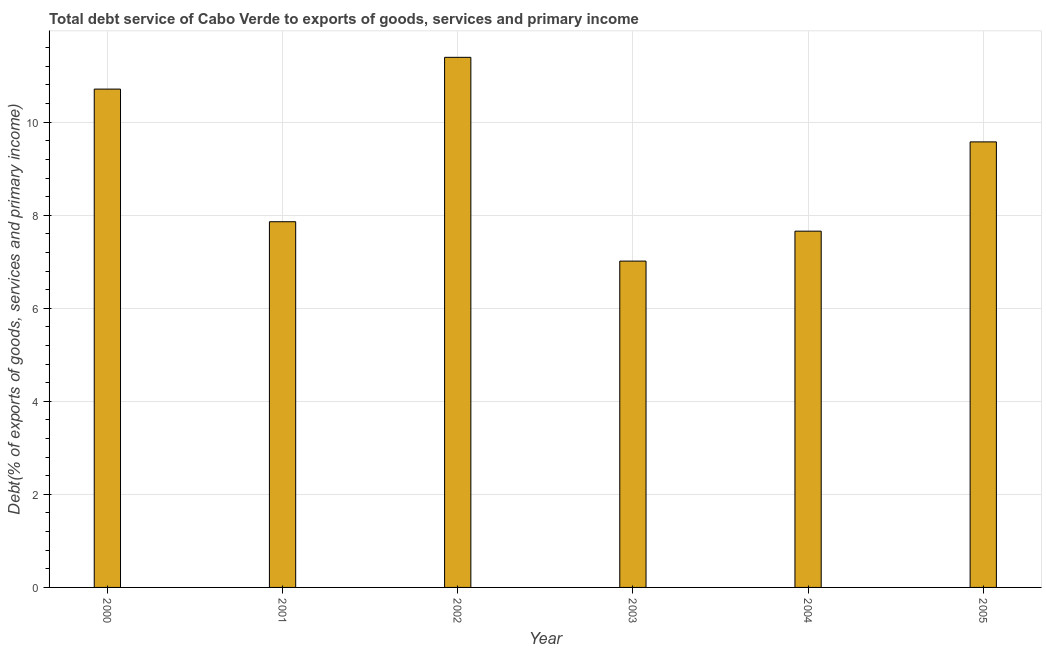Does the graph contain any zero values?
Provide a succinct answer. No. Does the graph contain grids?
Give a very brief answer. Yes. What is the title of the graph?
Keep it short and to the point. Total debt service of Cabo Verde to exports of goods, services and primary income. What is the label or title of the Y-axis?
Provide a short and direct response. Debt(% of exports of goods, services and primary income). What is the total debt service in 2004?
Your response must be concise. 7.66. Across all years, what is the maximum total debt service?
Your answer should be very brief. 11.39. Across all years, what is the minimum total debt service?
Ensure brevity in your answer.  7.01. In which year was the total debt service maximum?
Make the answer very short. 2002. What is the sum of the total debt service?
Keep it short and to the point. 54.21. What is the difference between the total debt service in 2001 and 2004?
Make the answer very short. 0.2. What is the average total debt service per year?
Make the answer very short. 9.04. What is the median total debt service?
Make the answer very short. 8.72. Is the total debt service in 2000 less than that in 2004?
Offer a terse response. No. Is the difference between the total debt service in 2003 and 2004 greater than the difference between any two years?
Provide a succinct answer. No. What is the difference between the highest and the second highest total debt service?
Keep it short and to the point. 0.68. Is the sum of the total debt service in 2002 and 2004 greater than the maximum total debt service across all years?
Offer a very short reply. Yes. What is the difference between the highest and the lowest total debt service?
Your response must be concise. 4.38. Are all the bars in the graph horizontal?
Your answer should be very brief. No. How many years are there in the graph?
Your answer should be very brief. 6. Are the values on the major ticks of Y-axis written in scientific E-notation?
Provide a succinct answer. No. What is the Debt(% of exports of goods, services and primary income) of 2000?
Your response must be concise. 10.71. What is the Debt(% of exports of goods, services and primary income) of 2001?
Offer a terse response. 7.86. What is the Debt(% of exports of goods, services and primary income) of 2002?
Ensure brevity in your answer.  11.39. What is the Debt(% of exports of goods, services and primary income) in 2003?
Offer a terse response. 7.01. What is the Debt(% of exports of goods, services and primary income) in 2004?
Make the answer very short. 7.66. What is the Debt(% of exports of goods, services and primary income) in 2005?
Offer a terse response. 9.58. What is the difference between the Debt(% of exports of goods, services and primary income) in 2000 and 2001?
Keep it short and to the point. 2.85. What is the difference between the Debt(% of exports of goods, services and primary income) in 2000 and 2002?
Offer a terse response. -0.68. What is the difference between the Debt(% of exports of goods, services and primary income) in 2000 and 2003?
Offer a very short reply. 3.7. What is the difference between the Debt(% of exports of goods, services and primary income) in 2000 and 2004?
Keep it short and to the point. 3.05. What is the difference between the Debt(% of exports of goods, services and primary income) in 2000 and 2005?
Make the answer very short. 1.13. What is the difference between the Debt(% of exports of goods, services and primary income) in 2001 and 2002?
Provide a short and direct response. -3.53. What is the difference between the Debt(% of exports of goods, services and primary income) in 2001 and 2003?
Offer a terse response. 0.85. What is the difference between the Debt(% of exports of goods, services and primary income) in 2001 and 2004?
Provide a succinct answer. 0.2. What is the difference between the Debt(% of exports of goods, services and primary income) in 2001 and 2005?
Your answer should be very brief. -1.72. What is the difference between the Debt(% of exports of goods, services and primary income) in 2002 and 2003?
Keep it short and to the point. 4.38. What is the difference between the Debt(% of exports of goods, services and primary income) in 2002 and 2004?
Offer a very short reply. 3.74. What is the difference between the Debt(% of exports of goods, services and primary income) in 2002 and 2005?
Your response must be concise. 1.82. What is the difference between the Debt(% of exports of goods, services and primary income) in 2003 and 2004?
Offer a very short reply. -0.64. What is the difference between the Debt(% of exports of goods, services and primary income) in 2003 and 2005?
Keep it short and to the point. -2.56. What is the difference between the Debt(% of exports of goods, services and primary income) in 2004 and 2005?
Provide a short and direct response. -1.92. What is the ratio of the Debt(% of exports of goods, services and primary income) in 2000 to that in 2001?
Offer a very short reply. 1.36. What is the ratio of the Debt(% of exports of goods, services and primary income) in 2000 to that in 2003?
Offer a very short reply. 1.53. What is the ratio of the Debt(% of exports of goods, services and primary income) in 2000 to that in 2004?
Offer a very short reply. 1.4. What is the ratio of the Debt(% of exports of goods, services and primary income) in 2000 to that in 2005?
Ensure brevity in your answer.  1.12. What is the ratio of the Debt(% of exports of goods, services and primary income) in 2001 to that in 2002?
Keep it short and to the point. 0.69. What is the ratio of the Debt(% of exports of goods, services and primary income) in 2001 to that in 2003?
Ensure brevity in your answer.  1.12. What is the ratio of the Debt(% of exports of goods, services and primary income) in 2001 to that in 2004?
Keep it short and to the point. 1.03. What is the ratio of the Debt(% of exports of goods, services and primary income) in 2001 to that in 2005?
Provide a short and direct response. 0.82. What is the ratio of the Debt(% of exports of goods, services and primary income) in 2002 to that in 2003?
Provide a succinct answer. 1.62. What is the ratio of the Debt(% of exports of goods, services and primary income) in 2002 to that in 2004?
Your answer should be compact. 1.49. What is the ratio of the Debt(% of exports of goods, services and primary income) in 2002 to that in 2005?
Offer a very short reply. 1.19. What is the ratio of the Debt(% of exports of goods, services and primary income) in 2003 to that in 2004?
Ensure brevity in your answer.  0.92. What is the ratio of the Debt(% of exports of goods, services and primary income) in 2003 to that in 2005?
Your answer should be very brief. 0.73. What is the ratio of the Debt(% of exports of goods, services and primary income) in 2004 to that in 2005?
Your answer should be compact. 0.8. 